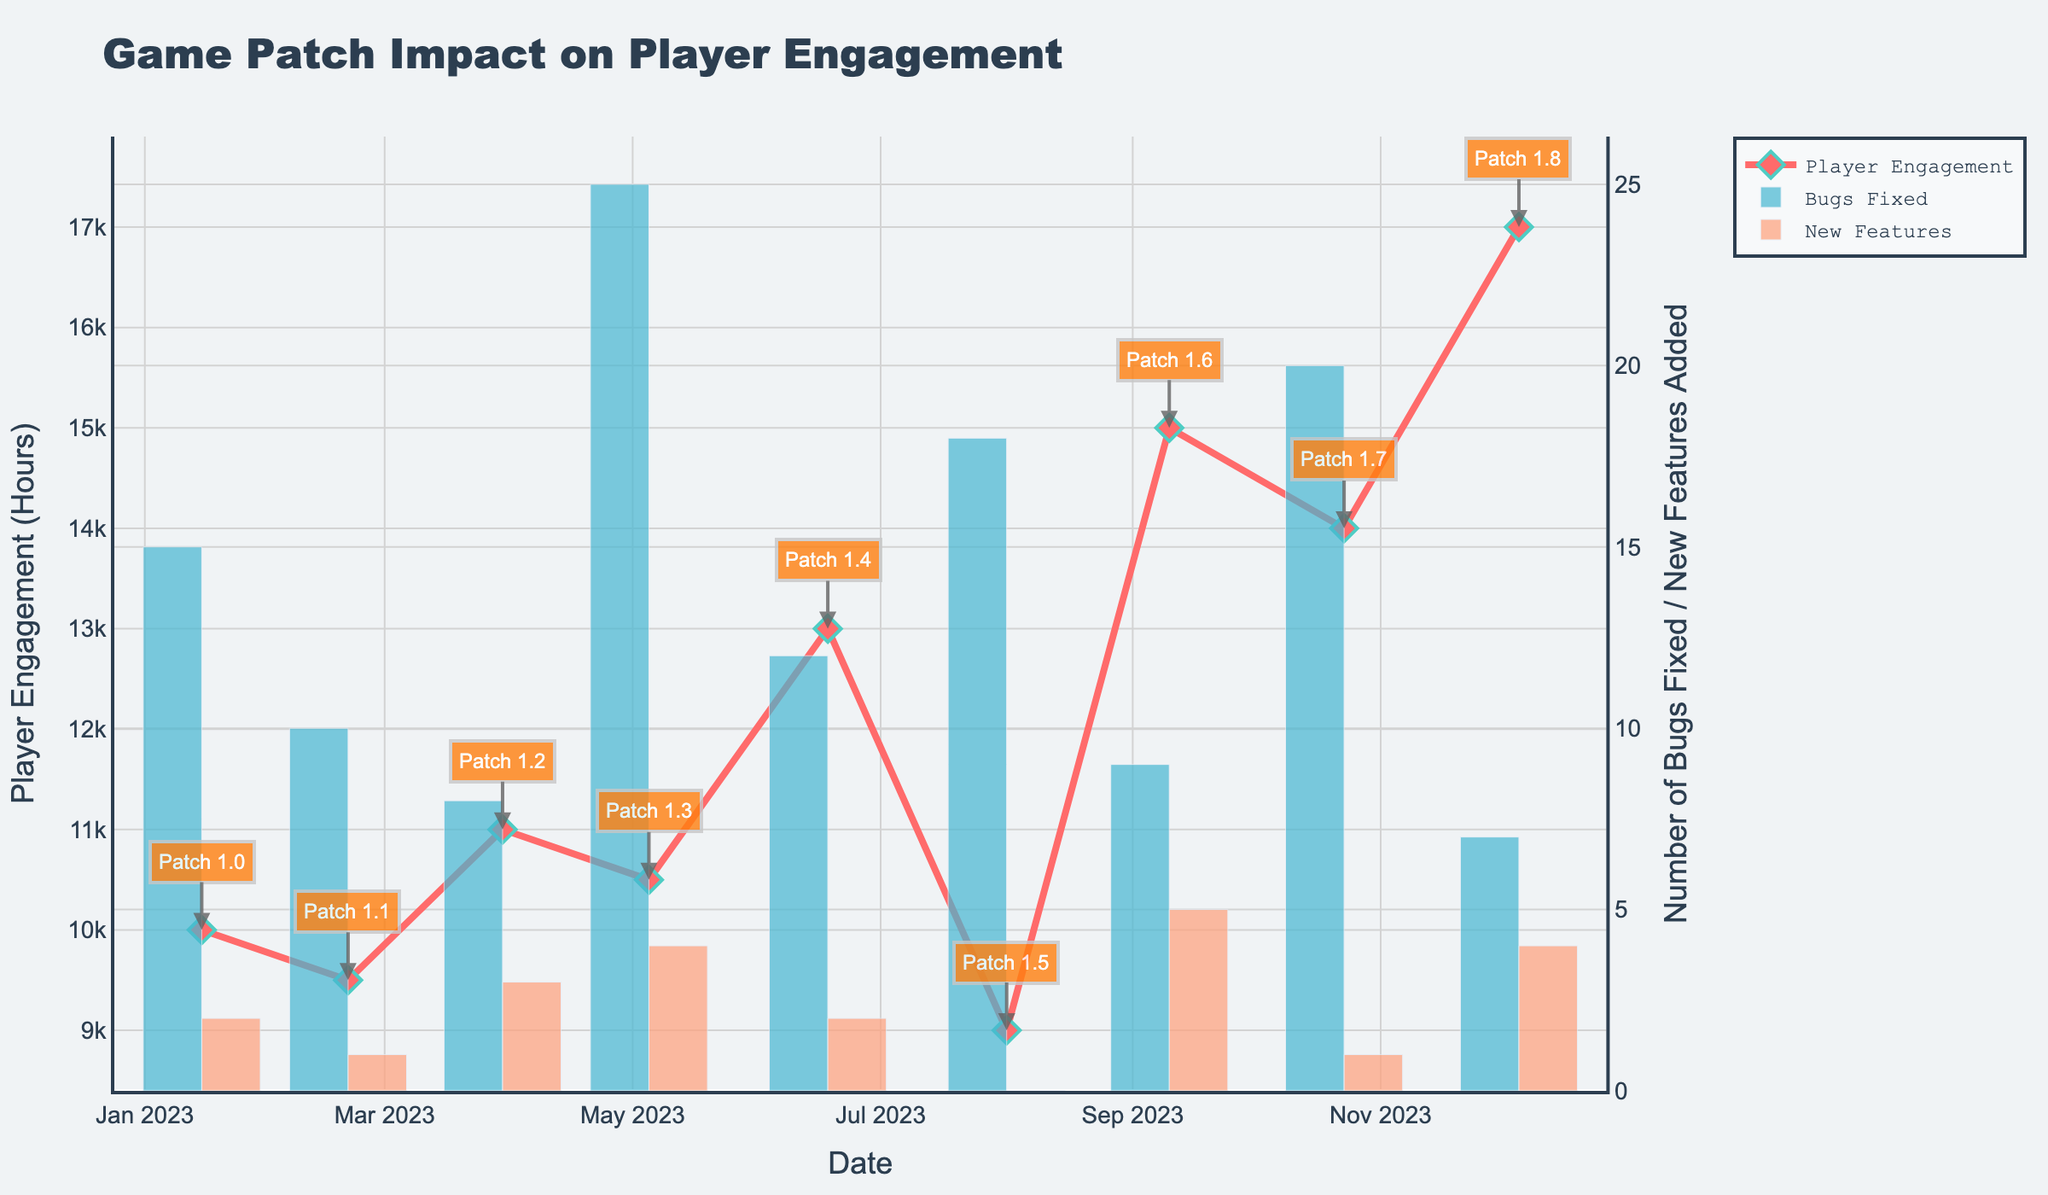What is the title of the plot? The title is positioned at the top of the plot and usually describes the overall topic or what the plot is about.
Answer: Game Patch Impact on Player Engagement How many patches are represented in the figure? Each data point on the plot corresponds to a patch, which can be counted along the x-axis.
Answer: 9 Which patch had the highest Player Engagement? Find the highest point in the Player Engagement line and note the corresponding patch name.
Answer: Patch 1.8 On what date was Patch 1.4 released? Locate Patch 1.4 on the x-axis of the plot to find its corresponding date.
Answer: 2023-06-18 How many bugs were fixed in Patch 1.3? Locate Patch 1.3 on the x-axis, then refer to the bar representing the number of bugs fixed.
Answer: 25 Which patch had the lowest Player Engagement? Find the lowest point in the Player Engagement line and note the corresponding patch name.
Answer: Patch 1.5 How many new features were added in patches released in January and February 2023 combined? Locate patches released in January and February 2023, sum the heights of the bars representing new features added.
Answer: 3 Which patch had the most new features added? Find the highest bar for new features added and note the corresponding patch name.
Answer: Patch 1.6 Is there a correlation between the number of bugs fixed and Player Engagement? Examine the plot to see if higher numbers of bugs fixed generally correspond to higher or lower Player Engagement. Describe the trend observed.
Answer: No clear correlation What trends do you observe in Player Engagement over time? Look at the line representing Player Engagement and describe the overall trend from January 2023 to December 2023.
Answer: General increase with fluctuations 